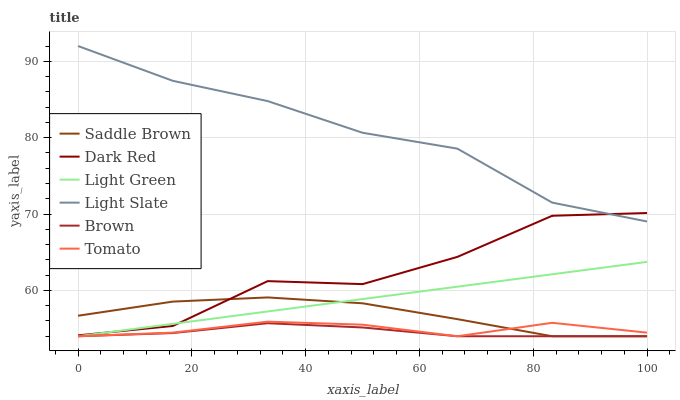Does Brown have the minimum area under the curve?
Answer yes or no. Yes. Does Light Slate have the maximum area under the curve?
Answer yes or no. Yes. Does Light Slate have the minimum area under the curve?
Answer yes or no. No. Does Brown have the maximum area under the curve?
Answer yes or no. No. Is Light Green the smoothest?
Answer yes or no. Yes. Is Dark Red the roughest?
Answer yes or no. Yes. Is Brown the smoothest?
Answer yes or no. No. Is Brown the roughest?
Answer yes or no. No. Does Tomato have the lowest value?
Answer yes or no. Yes. Does Light Slate have the lowest value?
Answer yes or no. No. Does Light Slate have the highest value?
Answer yes or no. Yes. Does Brown have the highest value?
Answer yes or no. No. Is Brown less than Light Slate?
Answer yes or no. Yes. Is Light Slate greater than Brown?
Answer yes or no. Yes. Does Brown intersect Saddle Brown?
Answer yes or no. Yes. Is Brown less than Saddle Brown?
Answer yes or no. No. Is Brown greater than Saddle Brown?
Answer yes or no. No. Does Brown intersect Light Slate?
Answer yes or no. No. 